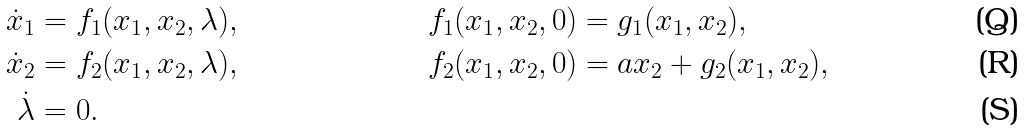<formula> <loc_0><loc_0><loc_500><loc_500>\dot { x } _ { 1 } & = f _ { 1 } ( x _ { 1 } , x _ { 2 } , \lambda ) , & f _ { 1 } ( x _ { 1 } , x _ { 2 } , 0 ) & = g _ { 1 } ( x _ { 1 } , x _ { 2 } ) , \\ \dot { x } _ { 2 } & = f _ { 2 } ( x _ { 1 } , x _ { 2 } , \lambda ) , & f _ { 2 } ( x _ { 1 } , x _ { 2 } , 0 ) & = a x _ { 2 } + g _ { 2 } ( x _ { 1 } , x _ { 2 } ) , \\ \dot { \lambda } & = 0 . & &</formula> 